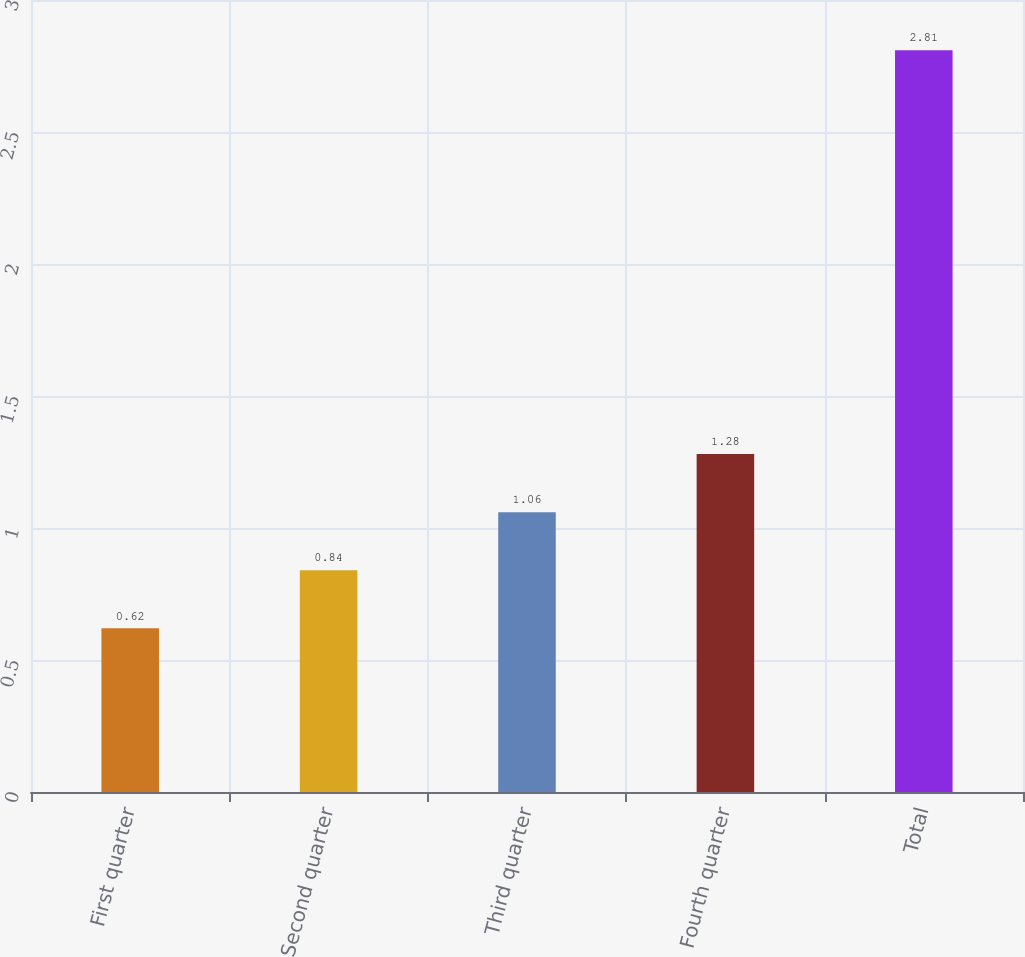<chart> <loc_0><loc_0><loc_500><loc_500><bar_chart><fcel>First quarter<fcel>Second quarter<fcel>Third quarter<fcel>Fourth quarter<fcel>Total<nl><fcel>0.62<fcel>0.84<fcel>1.06<fcel>1.28<fcel>2.81<nl></chart> 